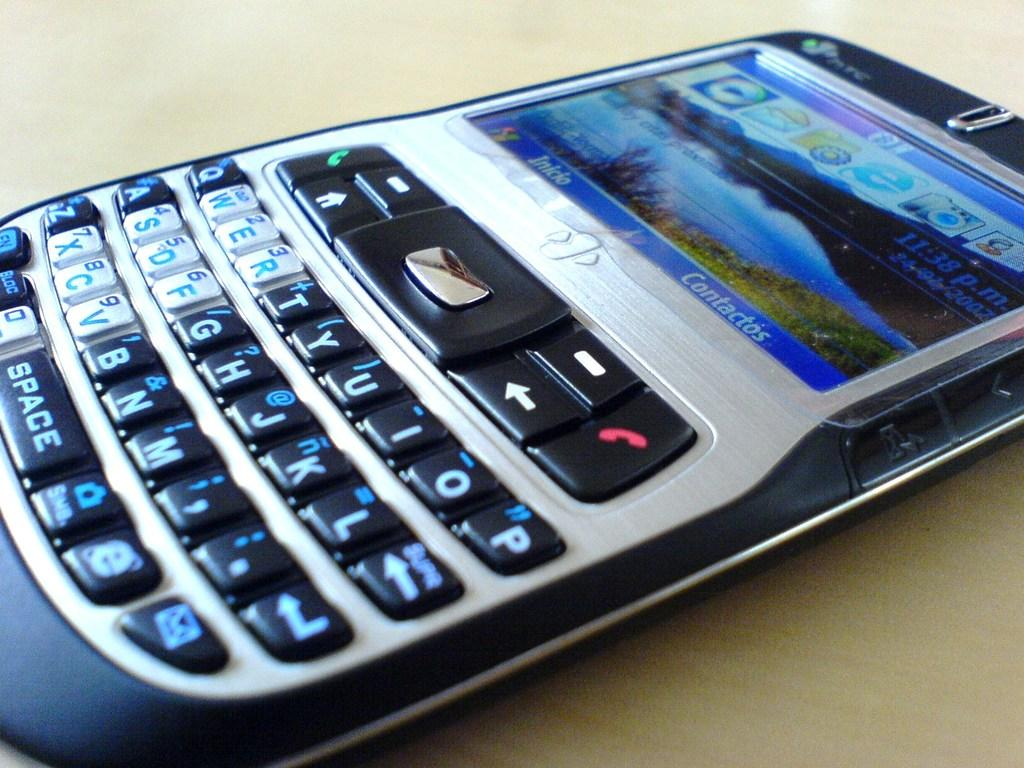<image>
Present a compact description of the photo's key features. An older cell phone with Contactos as one of the options to press on the screen. 